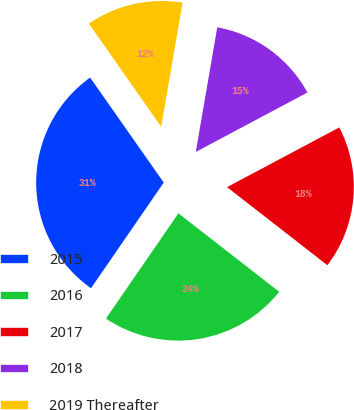Convert chart to OTSL. <chart><loc_0><loc_0><loc_500><loc_500><pie_chart><fcel>2015<fcel>2016<fcel>2017<fcel>2018<fcel>2019 Thereafter<nl><fcel>30.67%<fcel>24.07%<fcel>18.31%<fcel>14.5%<fcel>12.45%<nl></chart> 